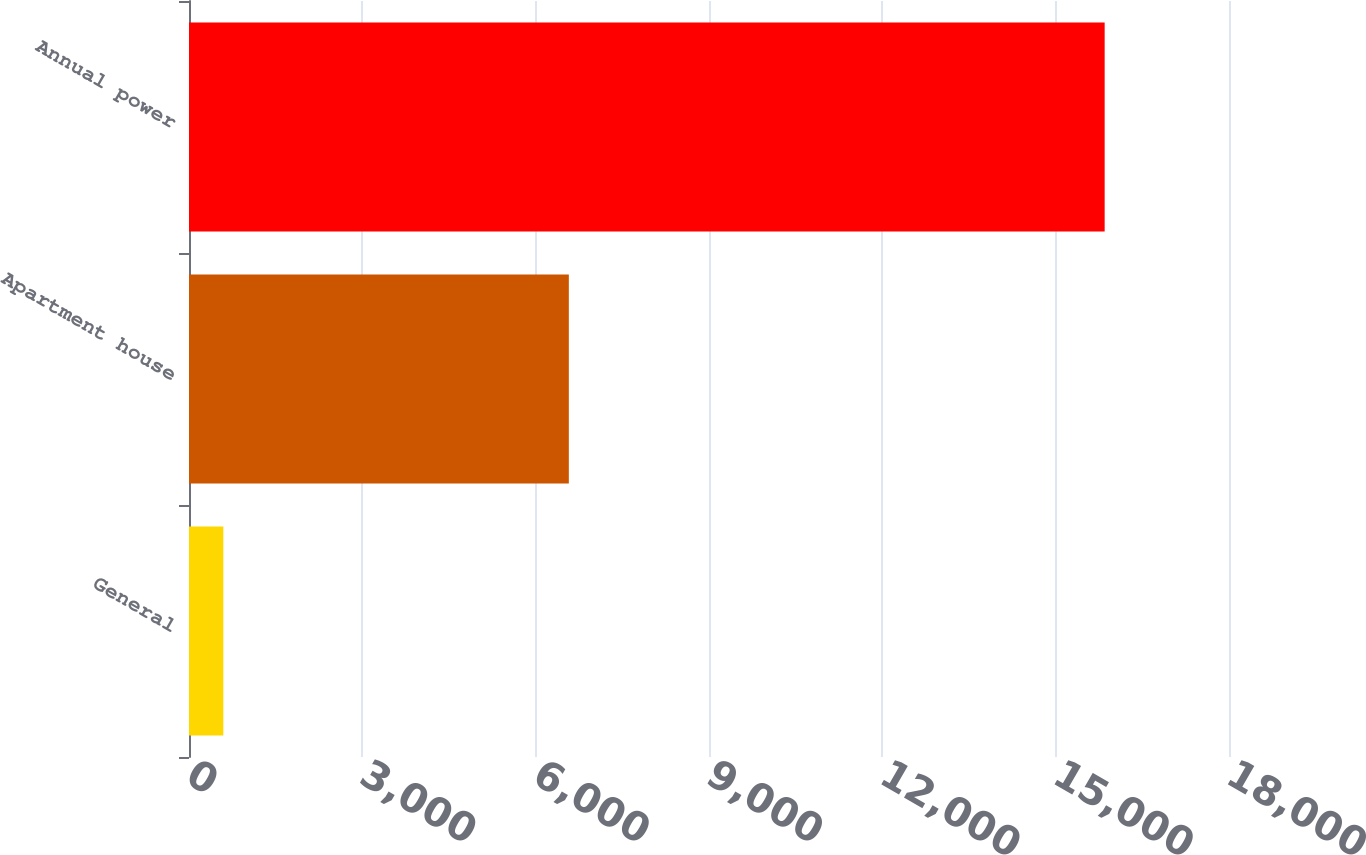Convert chart. <chart><loc_0><loc_0><loc_500><loc_500><bar_chart><fcel>General<fcel>Apartment house<fcel>Annual power<nl><fcel>594<fcel>6574<fcel>15848<nl></chart> 